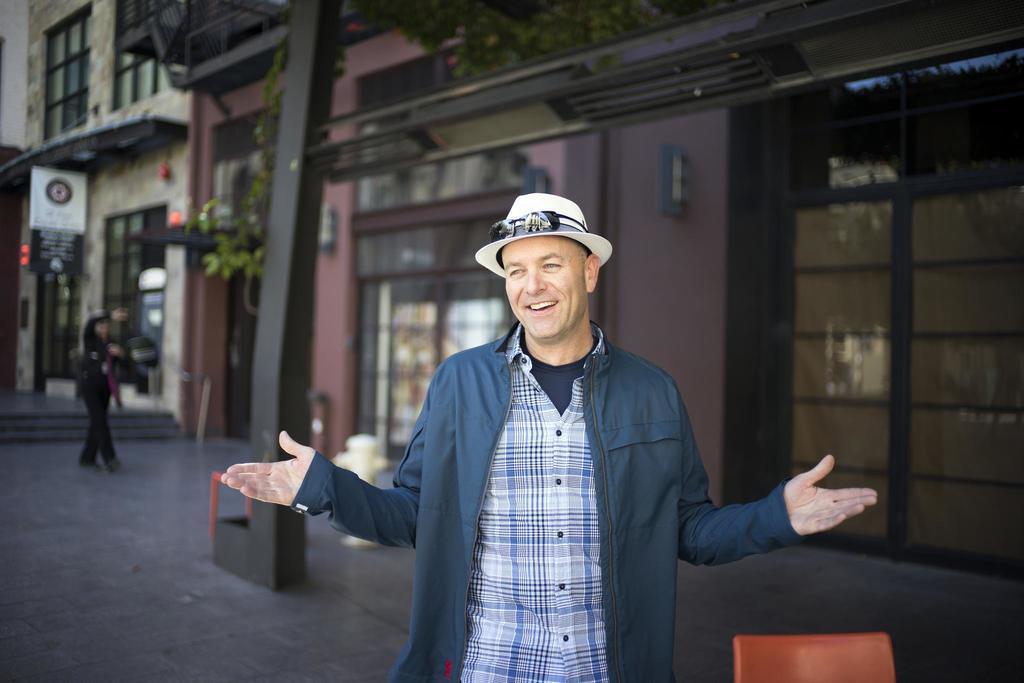How would you summarize this image in a sentence or two? In this picture I can see there is a man standing, he is wearing a coat, hat, glasses and he is smiling and there is another person on to left and there is a building in the backdrop. There is a chair at right side of the image. 